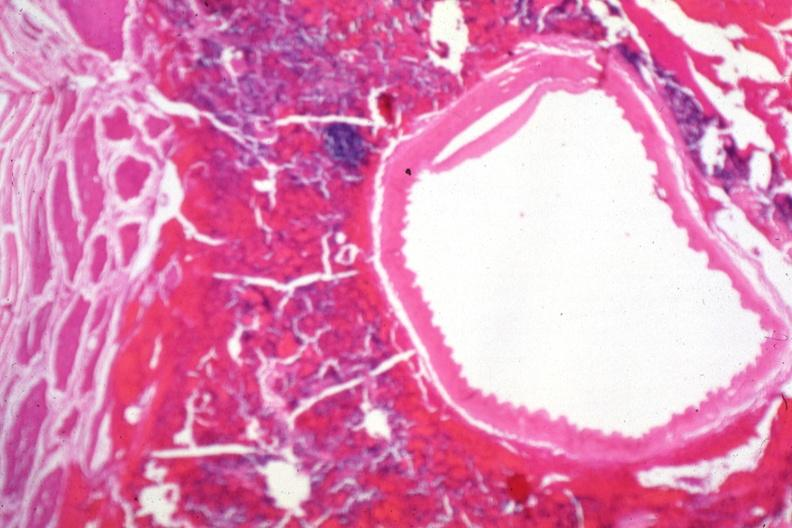s aldehyde fuscin present?
Answer the question using a single word or phrase. No 